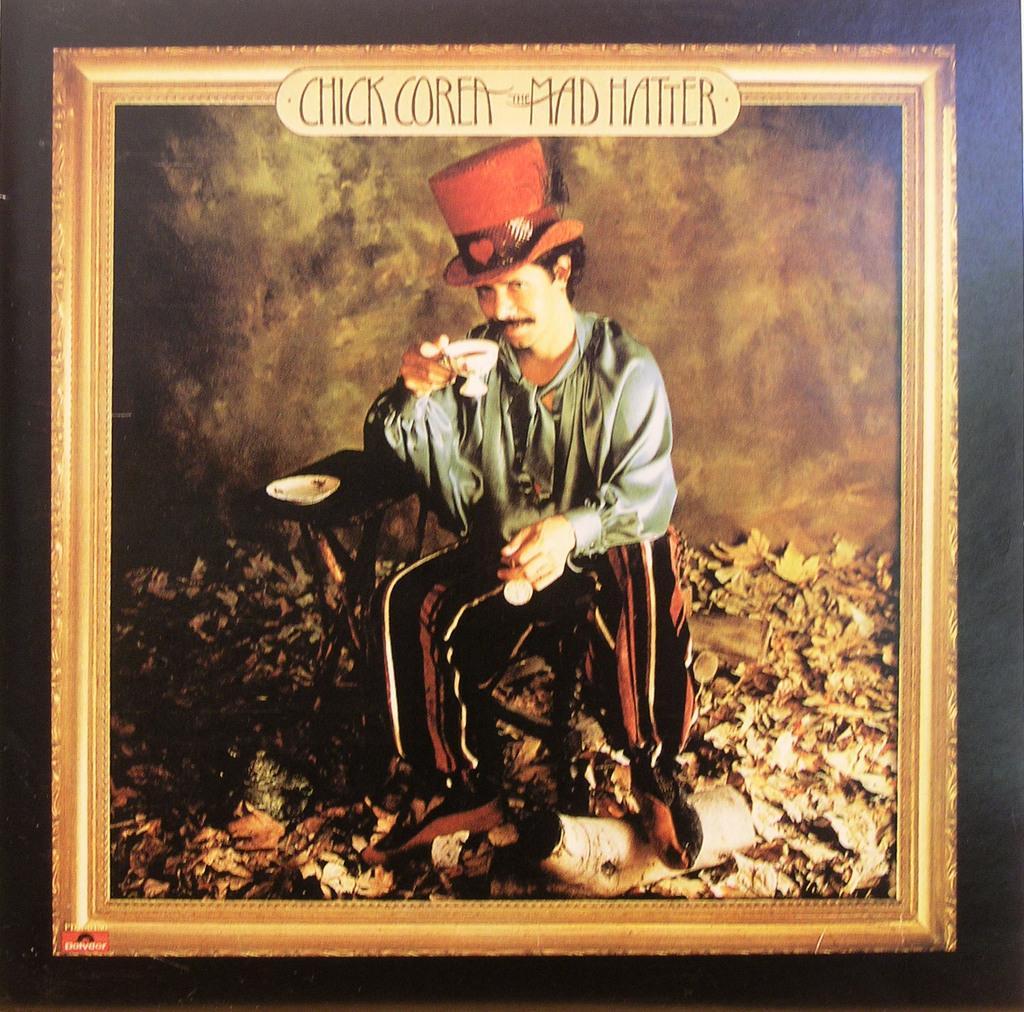Please provide a concise description of this image. This is a picture frame where we can see a person holding a cup with some drink in one of his hands and an object on the other hand, there we can also see live, some objects on the ground, we can also see a plate on a table behind the person and some text written on the frame. 